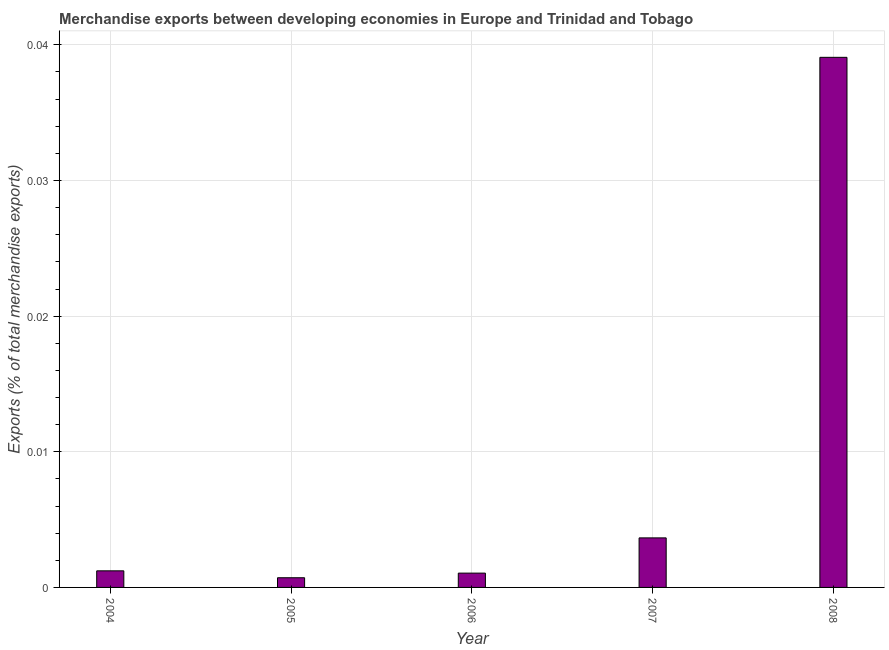Does the graph contain any zero values?
Make the answer very short. No. What is the title of the graph?
Your response must be concise. Merchandise exports between developing economies in Europe and Trinidad and Tobago. What is the label or title of the X-axis?
Ensure brevity in your answer.  Year. What is the label or title of the Y-axis?
Make the answer very short. Exports (% of total merchandise exports). What is the merchandise exports in 2008?
Keep it short and to the point. 0.04. Across all years, what is the maximum merchandise exports?
Provide a short and direct response. 0.04. Across all years, what is the minimum merchandise exports?
Your response must be concise. 0. In which year was the merchandise exports minimum?
Offer a very short reply. 2005. What is the sum of the merchandise exports?
Your response must be concise. 0.05. What is the difference between the merchandise exports in 2005 and 2007?
Offer a very short reply. -0. What is the average merchandise exports per year?
Give a very brief answer. 0.01. What is the median merchandise exports?
Provide a succinct answer. 0. What is the ratio of the merchandise exports in 2005 to that in 2007?
Offer a terse response. 0.2. Is the difference between the merchandise exports in 2004 and 2006 greater than the difference between any two years?
Make the answer very short. No. What is the difference between the highest and the second highest merchandise exports?
Keep it short and to the point. 0.04. Is the sum of the merchandise exports in 2005 and 2008 greater than the maximum merchandise exports across all years?
Offer a terse response. Yes. In how many years, is the merchandise exports greater than the average merchandise exports taken over all years?
Provide a short and direct response. 1. How many years are there in the graph?
Offer a terse response. 5. What is the difference between two consecutive major ticks on the Y-axis?
Give a very brief answer. 0.01. What is the Exports (% of total merchandise exports) of 2004?
Make the answer very short. 0. What is the Exports (% of total merchandise exports) in 2005?
Your response must be concise. 0. What is the Exports (% of total merchandise exports) in 2006?
Provide a short and direct response. 0. What is the Exports (% of total merchandise exports) of 2007?
Give a very brief answer. 0. What is the Exports (% of total merchandise exports) of 2008?
Keep it short and to the point. 0.04. What is the difference between the Exports (% of total merchandise exports) in 2004 and 2005?
Make the answer very short. 0. What is the difference between the Exports (% of total merchandise exports) in 2004 and 2006?
Keep it short and to the point. 0. What is the difference between the Exports (% of total merchandise exports) in 2004 and 2007?
Your answer should be very brief. -0. What is the difference between the Exports (% of total merchandise exports) in 2004 and 2008?
Keep it short and to the point. -0.04. What is the difference between the Exports (% of total merchandise exports) in 2005 and 2006?
Keep it short and to the point. -0. What is the difference between the Exports (% of total merchandise exports) in 2005 and 2007?
Make the answer very short. -0. What is the difference between the Exports (% of total merchandise exports) in 2005 and 2008?
Ensure brevity in your answer.  -0.04. What is the difference between the Exports (% of total merchandise exports) in 2006 and 2007?
Your answer should be very brief. -0. What is the difference between the Exports (% of total merchandise exports) in 2006 and 2008?
Ensure brevity in your answer.  -0.04. What is the difference between the Exports (% of total merchandise exports) in 2007 and 2008?
Give a very brief answer. -0.04. What is the ratio of the Exports (% of total merchandise exports) in 2004 to that in 2005?
Make the answer very short. 1.71. What is the ratio of the Exports (% of total merchandise exports) in 2004 to that in 2006?
Your response must be concise. 1.16. What is the ratio of the Exports (% of total merchandise exports) in 2004 to that in 2007?
Give a very brief answer. 0.34. What is the ratio of the Exports (% of total merchandise exports) in 2004 to that in 2008?
Make the answer very short. 0.03. What is the ratio of the Exports (% of total merchandise exports) in 2005 to that in 2006?
Offer a very short reply. 0.68. What is the ratio of the Exports (% of total merchandise exports) in 2005 to that in 2007?
Give a very brief answer. 0.2. What is the ratio of the Exports (% of total merchandise exports) in 2005 to that in 2008?
Your answer should be very brief. 0.02. What is the ratio of the Exports (% of total merchandise exports) in 2006 to that in 2007?
Your answer should be compact. 0.29. What is the ratio of the Exports (% of total merchandise exports) in 2006 to that in 2008?
Ensure brevity in your answer.  0.03. What is the ratio of the Exports (% of total merchandise exports) in 2007 to that in 2008?
Keep it short and to the point. 0.09. 